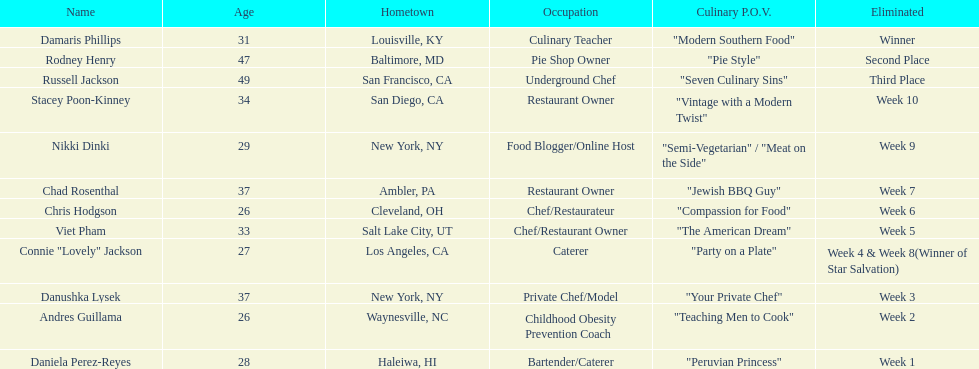Who was ousted initially, nikki dinki or viet pham? Viet Pham. 